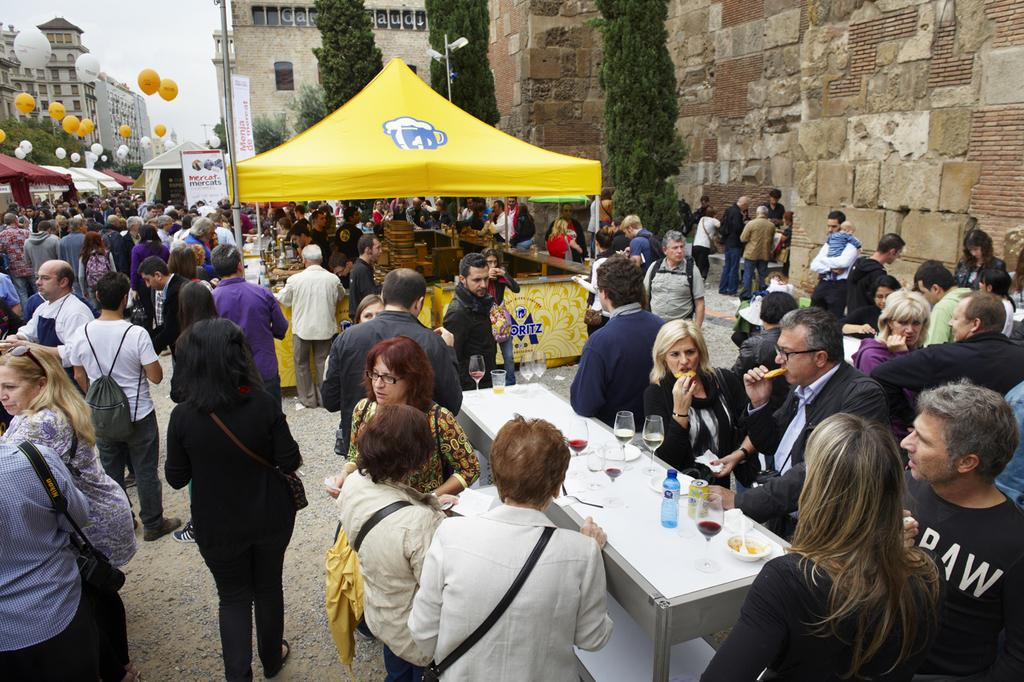What type of temporary shelters can be seen in the image? There are tents in the image. What decorative items are present in the image? There are balloons in the image. What type of furniture is visible in the image? There are tables in the image. What type of tableware can be seen in the image? There are glasses in the image. What type of beverage containers are present in the image? There are bottles in the image. How many people are present in the image? There are many people in the image. What structures can be seen in the background of the image? There are buildings, poles, trees, and banners in the background of the image. How does the river flow through the image? There is no river present in the image. What is the desire of the people in the image? The image does not provide information about the desires of the people. 